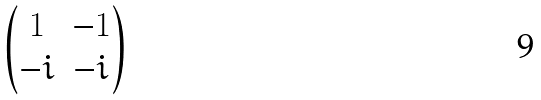Convert formula to latex. <formula><loc_0><loc_0><loc_500><loc_500>\begin{pmatrix} 1 & - 1 \\ - i & - i \\ \end{pmatrix}</formula> 